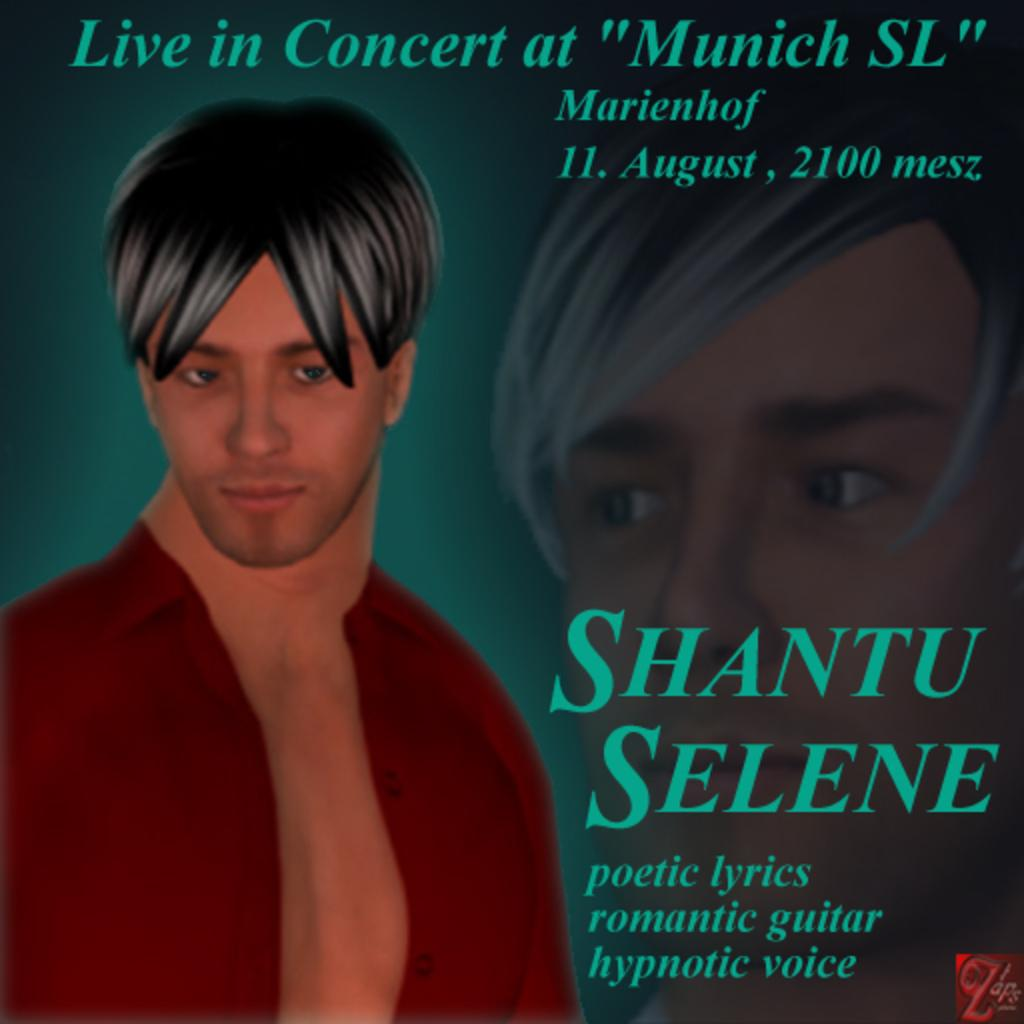What is the main subject in the foreground of the image? There is an image of a man in the foreground of the image. What else can be seen in the foreground of the image besides the man? There is some text in the foreground of the image. Can you describe the person's face visible on the right side of the image? There is a person's face visible on the right side of the image. What type of game is being played in the image? There is no game present in the image; it features an image of a man, text, and a person's face. 